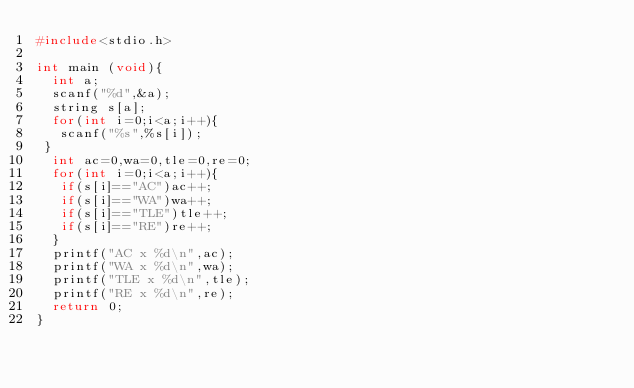Convert code to text. <code><loc_0><loc_0><loc_500><loc_500><_C_>#include<stdio.h> 

int main (void){
  int a;
  scanf("%d",&a);
  string s[a];
  for(int i=0;i<a;i++){
   scanf("%s",%s[i]);
 }
  int ac=0,wa=0,tle=0,re=0;
  for(int i=0;i<a;i++){
   if(s[i]=="AC")ac++;
   if(s[i]=="WA")wa++;
   if(s[i]=="TLE")tle++;
   if(s[i]=="RE")re++;
  }
  printf("AC x %d\n",ac);
  printf("WA x %d\n",wa);
  printf("TLE x %d\n",tle);
  printf("RE x %d\n",re);
  return 0;
}</code> 